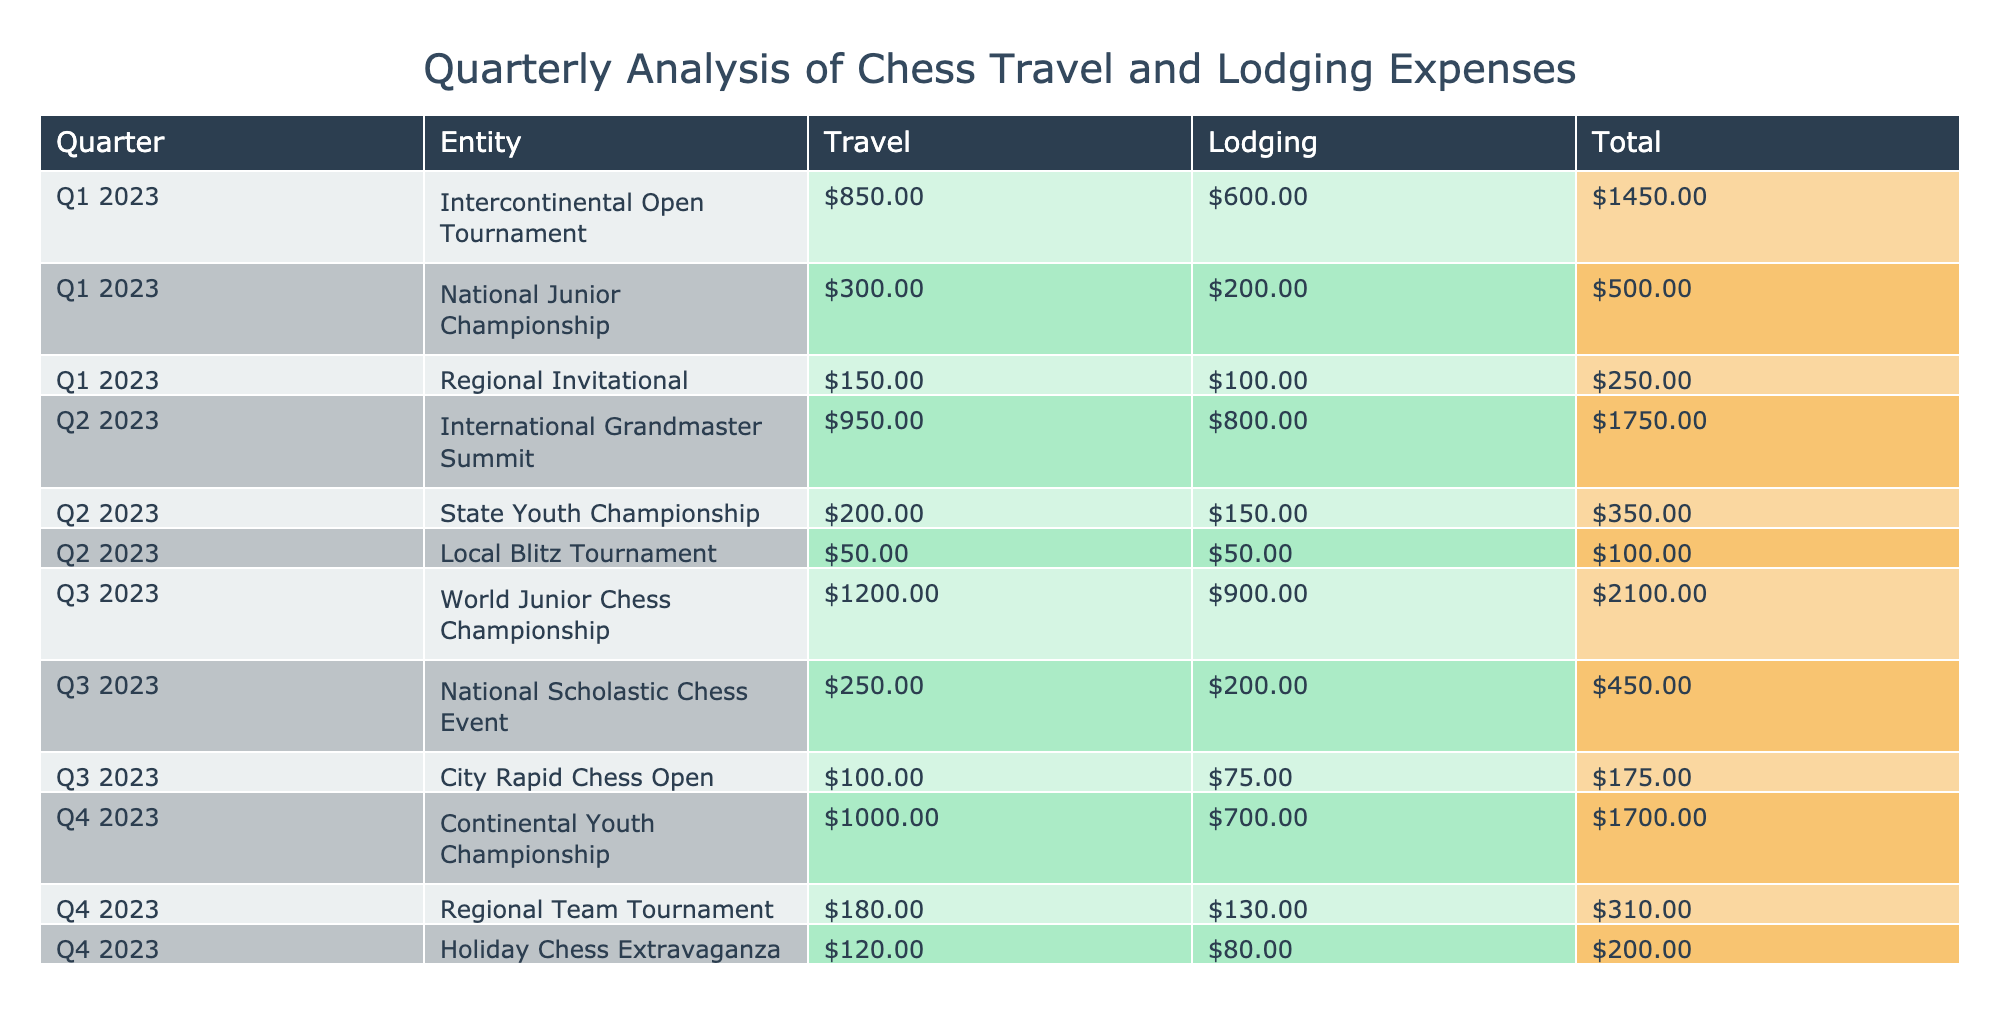What are the total Travel expenses for Q1 2023? The Travel expenses for Q1 2023 are from three events: Intercontinental Open Tournament ($850), National Junior Championship ($300), and Regional Invitational ($150). Adding these amounts gives us 850 + 300 + 150 = 1300.
Answer: 1300 Which event had the highest total expenses? To find the event with the highest total expenses, we must calculate the total for each event. For Intercontinental Open Tournament: 850 + 600 = 1450, National Junior Championship: 300 + 200 = 500, and so on. The World Junior Chess Championship has the highest total: 1200 (Travel) + 900 (Lodging) = 2100.
Answer: World Junior Chess Championship Is the total expense for Lodging in Q2 greater than in Q1? The total lodging in Q2 is 800 (International Grandmaster Summit) + 150 (State Youth Championship) + 50 (Local Blitz Tournament) = 1000. The total lodging in Q1 is 600 + 200 + 100 = 900. Since 1000 is greater than 900, the answer is yes.
Answer: Yes What is the average amount spent on Travel per quarter? To find the average, we first sum all the Travel expenses from each quarter: Q1: 1300, Q2: 1200, Q3: 1550, Q4: 1300. Adding these gives 1300 + 1200 + 1550 + 1300 = 6350. There are 4 quarters, so we divide 6350 by 4, resulting in 1587.5.
Answer: 1587.5 Did the lodging expenses decrease from Q3 to Q4? The lodging expense for Q3 is 900 + 75 + 200 = 1175, while for Q4 it is 700 + 130 + 80 = 910. Since 910 is less than 1175, this confirms that lodging expenses did decrease.
Answer: Yes 